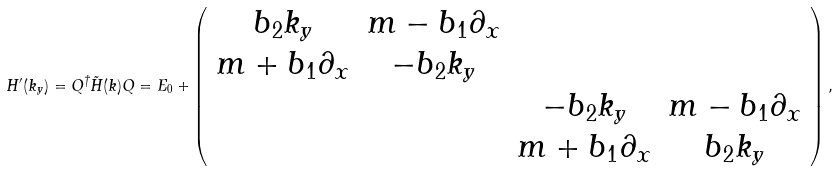Convert formula to latex. <formula><loc_0><loc_0><loc_500><loc_500>H ^ { \prime } ( k _ { y } ) = Q ^ { \dagger } \tilde { H } ( { k } ) Q = E _ { 0 } + \left ( \begin{array} { c c c c } b _ { 2 } k _ { y } & m - b _ { 1 } \partial _ { x } & & \\ m + b _ { 1 } \partial _ { x } & - b _ { 2 } k _ { y } & & \\ & & - b _ { 2 } k _ { y } & m - b _ { 1 } \partial _ { x } \\ & & m + b _ { 1 } \partial _ { x } & b _ { 2 } k _ { y } \end{array} \right ) ,</formula> 